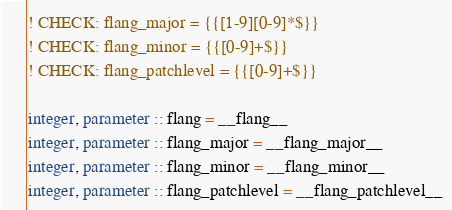<code> <loc_0><loc_0><loc_500><loc_500><_FORTRAN_>! CHECK: flang_major = {{[1-9][0-9]*$}}
! CHECK: flang_minor = {{[0-9]+$}}
! CHECK: flang_patchlevel = {{[0-9]+$}}

integer, parameter :: flang = __flang__
integer, parameter :: flang_major = __flang_major__
integer, parameter :: flang_minor = __flang_minor__
integer, parameter :: flang_patchlevel = __flang_patchlevel__
</code> 